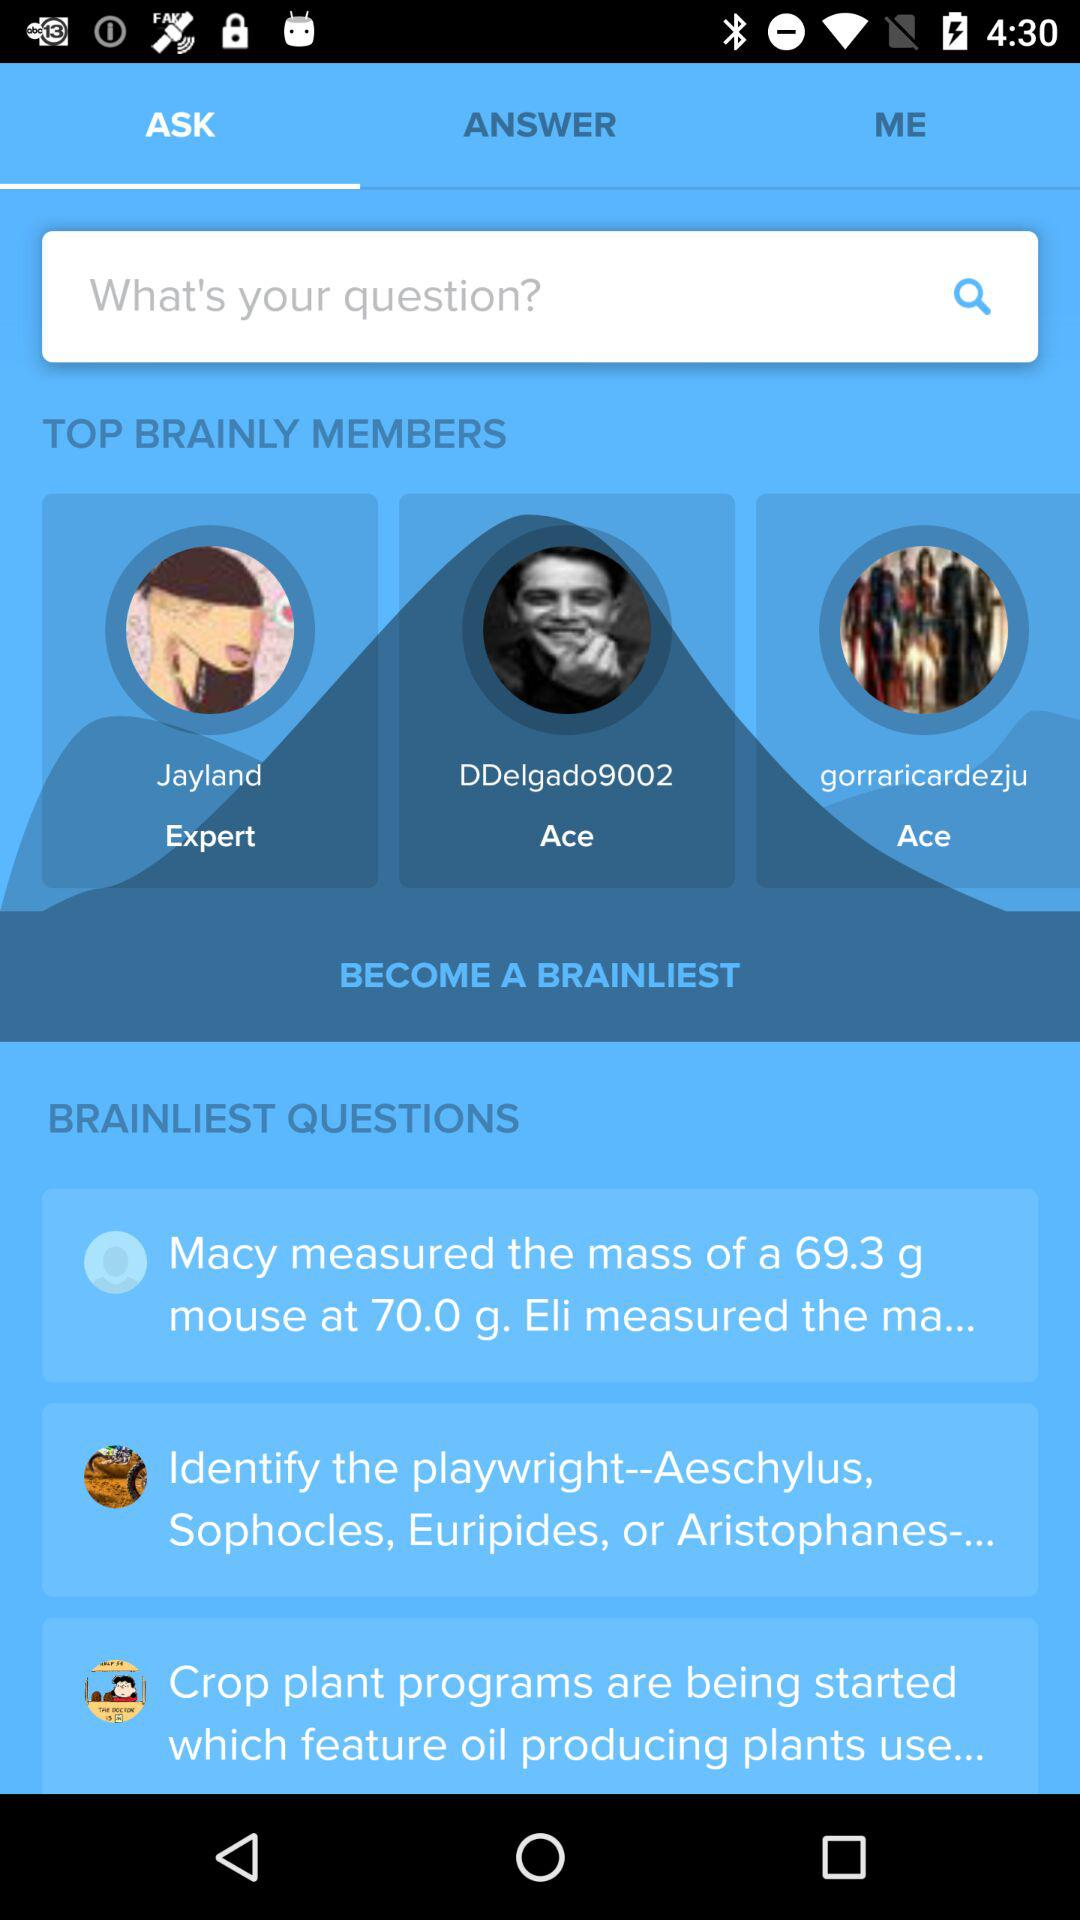What are the names of the top brainly members? The names are Jayland, DDelgado9002 and Gorraricardezju. 